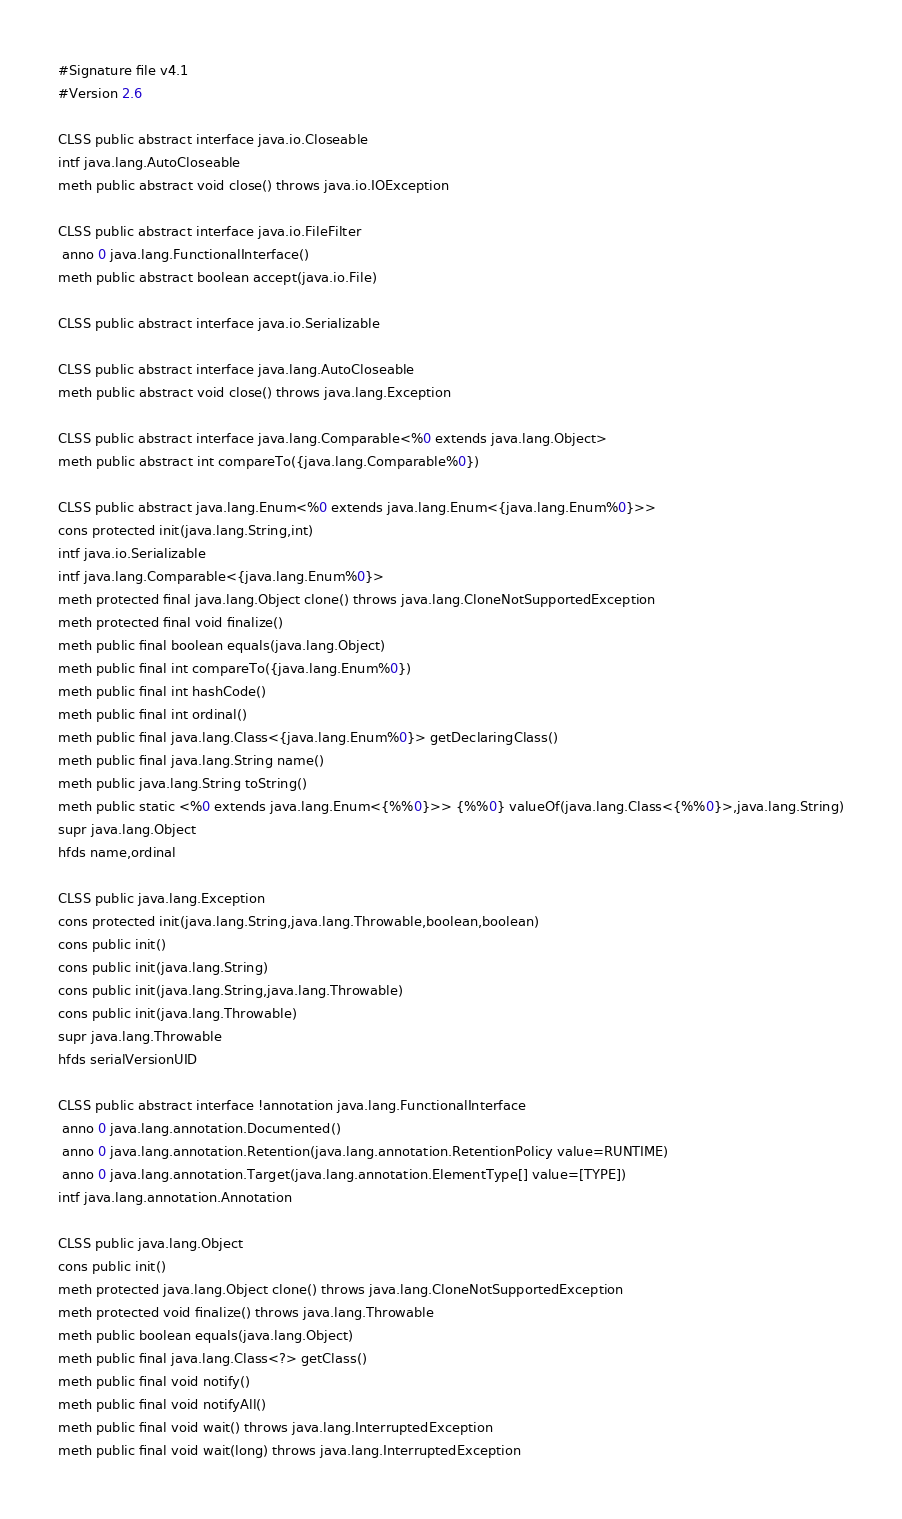Convert code to text. <code><loc_0><loc_0><loc_500><loc_500><_SML_>#Signature file v4.1
#Version 2.6

CLSS public abstract interface java.io.Closeable
intf java.lang.AutoCloseable
meth public abstract void close() throws java.io.IOException

CLSS public abstract interface java.io.FileFilter
 anno 0 java.lang.FunctionalInterface()
meth public abstract boolean accept(java.io.File)

CLSS public abstract interface java.io.Serializable

CLSS public abstract interface java.lang.AutoCloseable
meth public abstract void close() throws java.lang.Exception

CLSS public abstract interface java.lang.Comparable<%0 extends java.lang.Object>
meth public abstract int compareTo({java.lang.Comparable%0})

CLSS public abstract java.lang.Enum<%0 extends java.lang.Enum<{java.lang.Enum%0}>>
cons protected init(java.lang.String,int)
intf java.io.Serializable
intf java.lang.Comparable<{java.lang.Enum%0}>
meth protected final java.lang.Object clone() throws java.lang.CloneNotSupportedException
meth protected final void finalize()
meth public final boolean equals(java.lang.Object)
meth public final int compareTo({java.lang.Enum%0})
meth public final int hashCode()
meth public final int ordinal()
meth public final java.lang.Class<{java.lang.Enum%0}> getDeclaringClass()
meth public final java.lang.String name()
meth public java.lang.String toString()
meth public static <%0 extends java.lang.Enum<{%%0}>> {%%0} valueOf(java.lang.Class<{%%0}>,java.lang.String)
supr java.lang.Object
hfds name,ordinal

CLSS public java.lang.Exception
cons protected init(java.lang.String,java.lang.Throwable,boolean,boolean)
cons public init()
cons public init(java.lang.String)
cons public init(java.lang.String,java.lang.Throwable)
cons public init(java.lang.Throwable)
supr java.lang.Throwable
hfds serialVersionUID

CLSS public abstract interface !annotation java.lang.FunctionalInterface
 anno 0 java.lang.annotation.Documented()
 anno 0 java.lang.annotation.Retention(java.lang.annotation.RetentionPolicy value=RUNTIME)
 anno 0 java.lang.annotation.Target(java.lang.annotation.ElementType[] value=[TYPE])
intf java.lang.annotation.Annotation

CLSS public java.lang.Object
cons public init()
meth protected java.lang.Object clone() throws java.lang.CloneNotSupportedException
meth protected void finalize() throws java.lang.Throwable
meth public boolean equals(java.lang.Object)
meth public final java.lang.Class<?> getClass()
meth public final void notify()
meth public final void notifyAll()
meth public final void wait() throws java.lang.InterruptedException
meth public final void wait(long) throws java.lang.InterruptedException</code> 